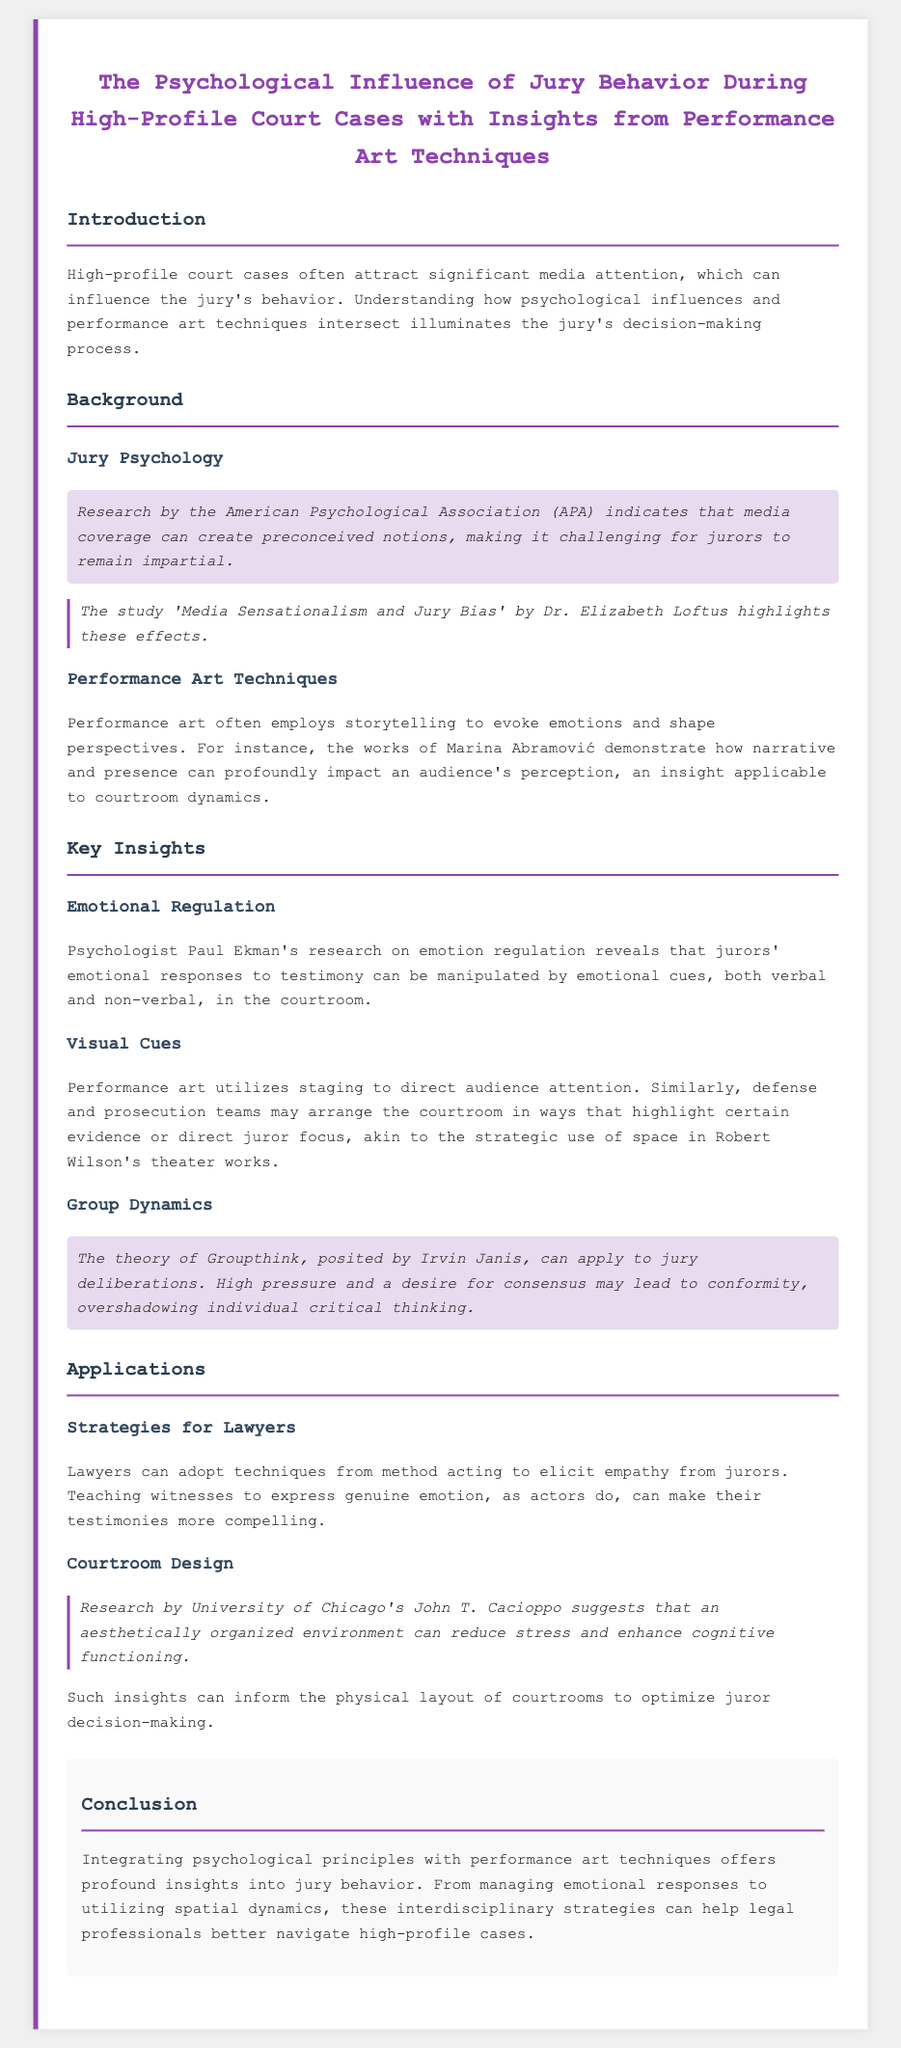What does the document analyze? The document analyzes the psychological influence of jury behavior during high-profile court cases with insights from performance art techniques.
Answer: Jury behavior Who conducted research on media coverage effects on jurors? The document refers to research conducted by the American Psychological Association concerning media coverage and its effects.
Answer: American Psychological Association Which psychologies author is mentioned for studying emotional regulation? The document mentions psychologist Paul Ekman for his research on emotional regulation.
Answer: Paul Ekman What theory is applied to jury deliberations in the document? The theory of Groupthink posited by Irvin Janis is applied to jury deliberations.
Answer: Groupthink Who suggested that courtroom design influences juror decision-making? The document refers to research by University of Chicago's John T. Cacioppo relating to courtroom design.
Answer: John T. Cacioppo 